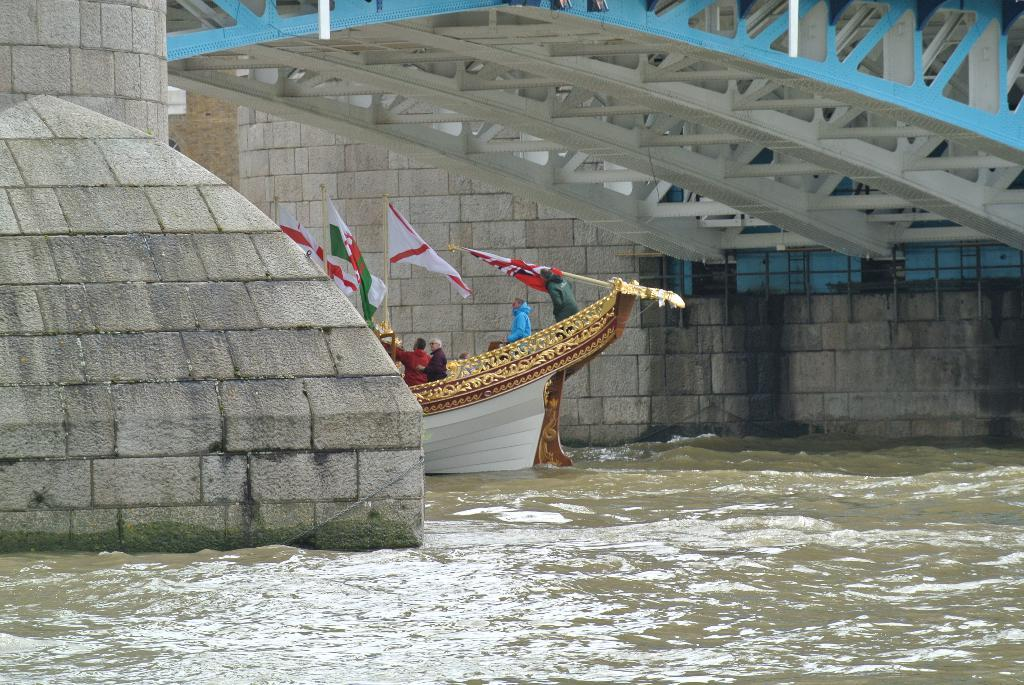What is the main subject in the middle of the image? There is a boat in the middle of the image. Who or what is inside the boat? There are people in the boat. Are there any decorations or symbols on the boat? Yes, there are flags in the boat. What can be seen at the top of the image? There appears to be a bridge at the top of the image. What is visible at the bottom of the image? Water is visible at the bottom of the image. How many stitches are visible on the boat's sail in the image? There is no sail or stitches present on the boat in the image. Are there any cobwebs hanging from the bridge in the image? There is no mention of cobwebs or a bridge with cobwebs in the image. 